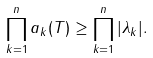Convert formula to latex. <formula><loc_0><loc_0><loc_500><loc_500>\prod _ { k = 1 } ^ { n } a _ { k } ( T ) \geq \prod _ { k = 1 } ^ { n } | \lambda _ { k } | .</formula> 